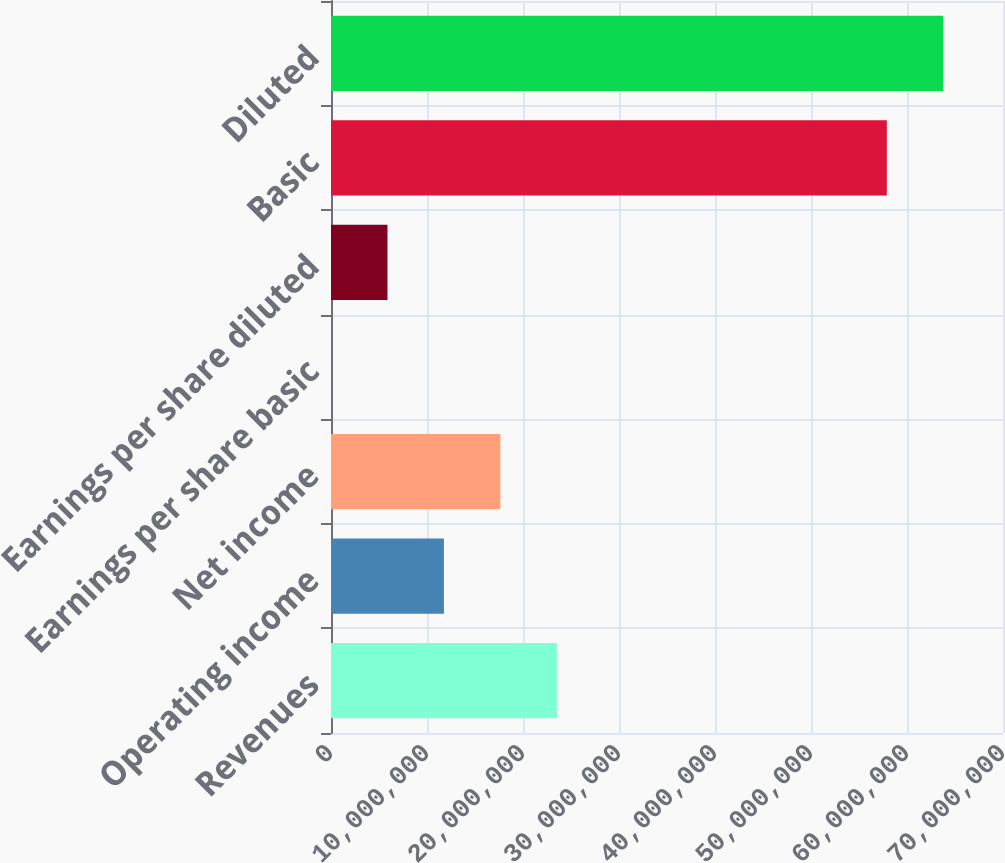Convert chart. <chart><loc_0><loc_0><loc_500><loc_500><bar_chart><fcel>Revenues<fcel>Operating income<fcel>Net income<fcel>Earnings per share basic<fcel>Earnings per share diluted<fcel>Basic<fcel>Diluted<nl><fcel>2.35266e+07<fcel>1.17633e+07<fcel>1.76449e+07<fcel>0.24<fcel>5.88164e+06<fcel>5.78989e+07<fcel>6.37806e+07<nl></chart> 